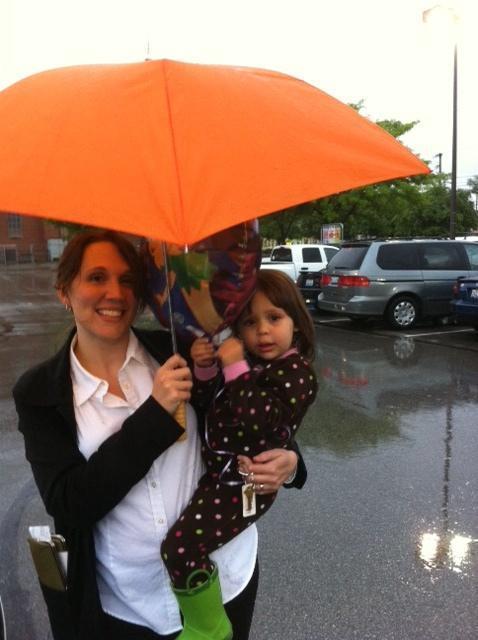How many cars in picture?
Give a very brief answer. 4. How many people can be seen?
Give a very brief answer. 2. How many train tracks are there?
Give a very brief answer. 0. 